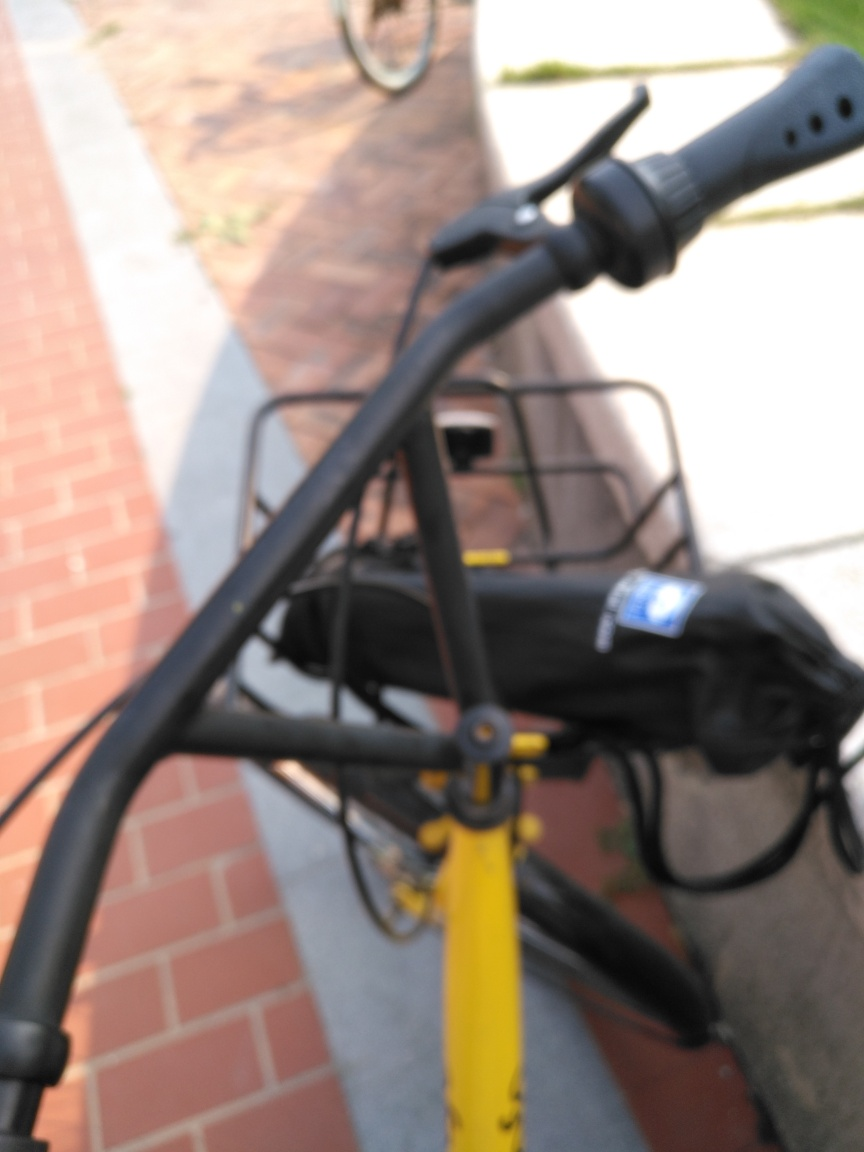Is the main subject clear and detailed in the image?
 No 